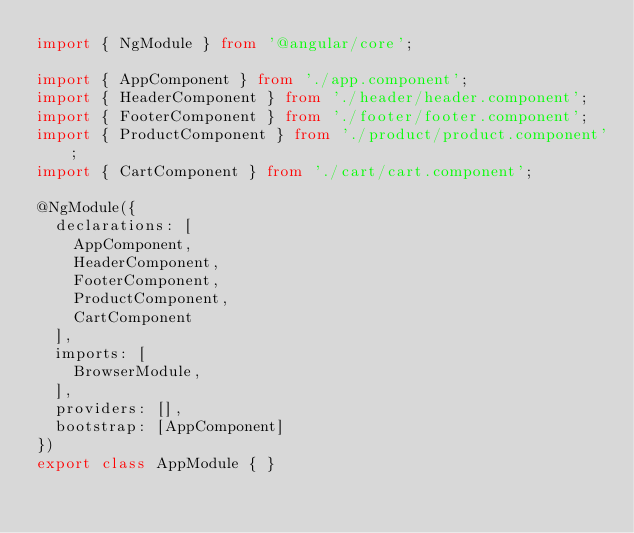Convert code to text. <code><loc_0><loc_0><loc_500><loc_500><_TypeScript_>import { NgModule } from '@angular/core';

import { AppComponent } from './app.component';
import { HeaderComponent } from './header/header.component';
import { FooterComponent } from './footer/footer.component';
import { ProductComponent } from './product/product.component';
import { CartComponent } from './cart/cart.component';

@NgModule({
  declarations: [
    AppComponent,
    HeaderComponent,
    FooterComponent,
    ProductComponent,
    CartComponent
  ],
  imports: [
    BrowserModule,
  ],
  providers: [],
  bootstrap: [AppComponent]
})
export class AppModule { }
</code> 